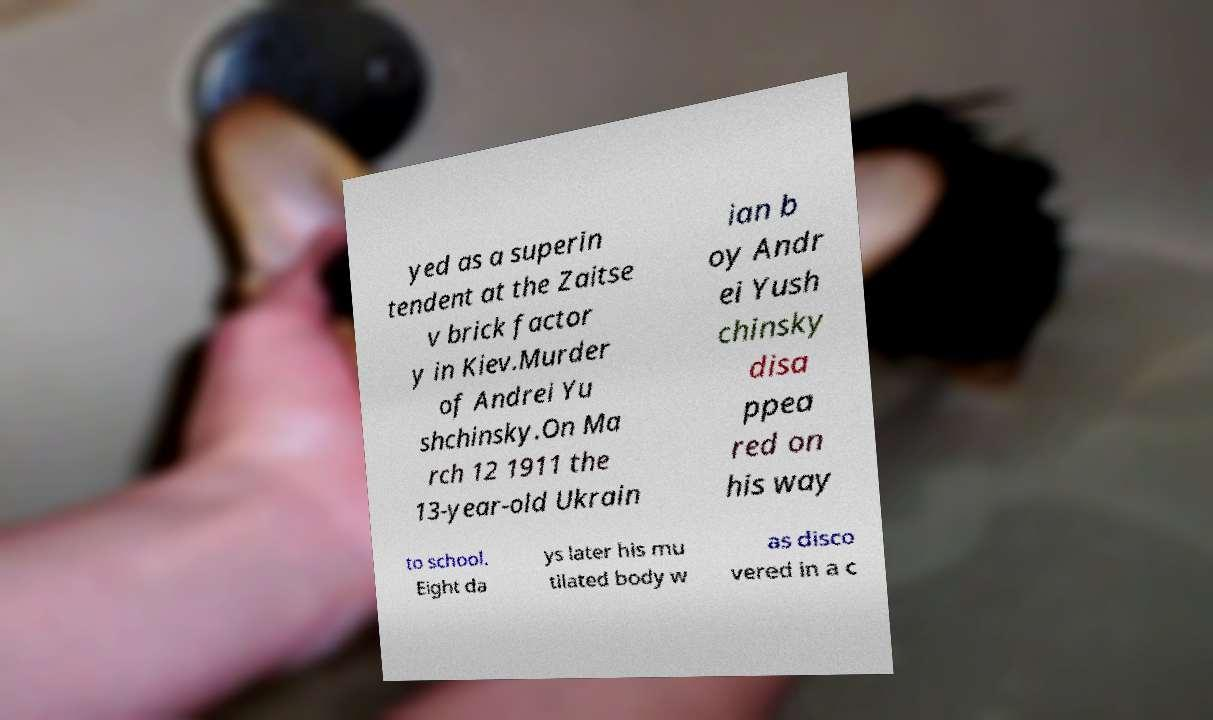Could you assist in decoding the text presented in this image and type it out clearly? yed as a superin tendent at the Zaitse v brick factor y in Kiev.Murder of Andrei Yu shchinsky.On Ma rch 12 1911 the 13-year-old Ukrain ian b oy Andr ei Yush chinsky disa ppea red on his way to school. Eight da ys later his mu tilated body w as disco vered in a c 